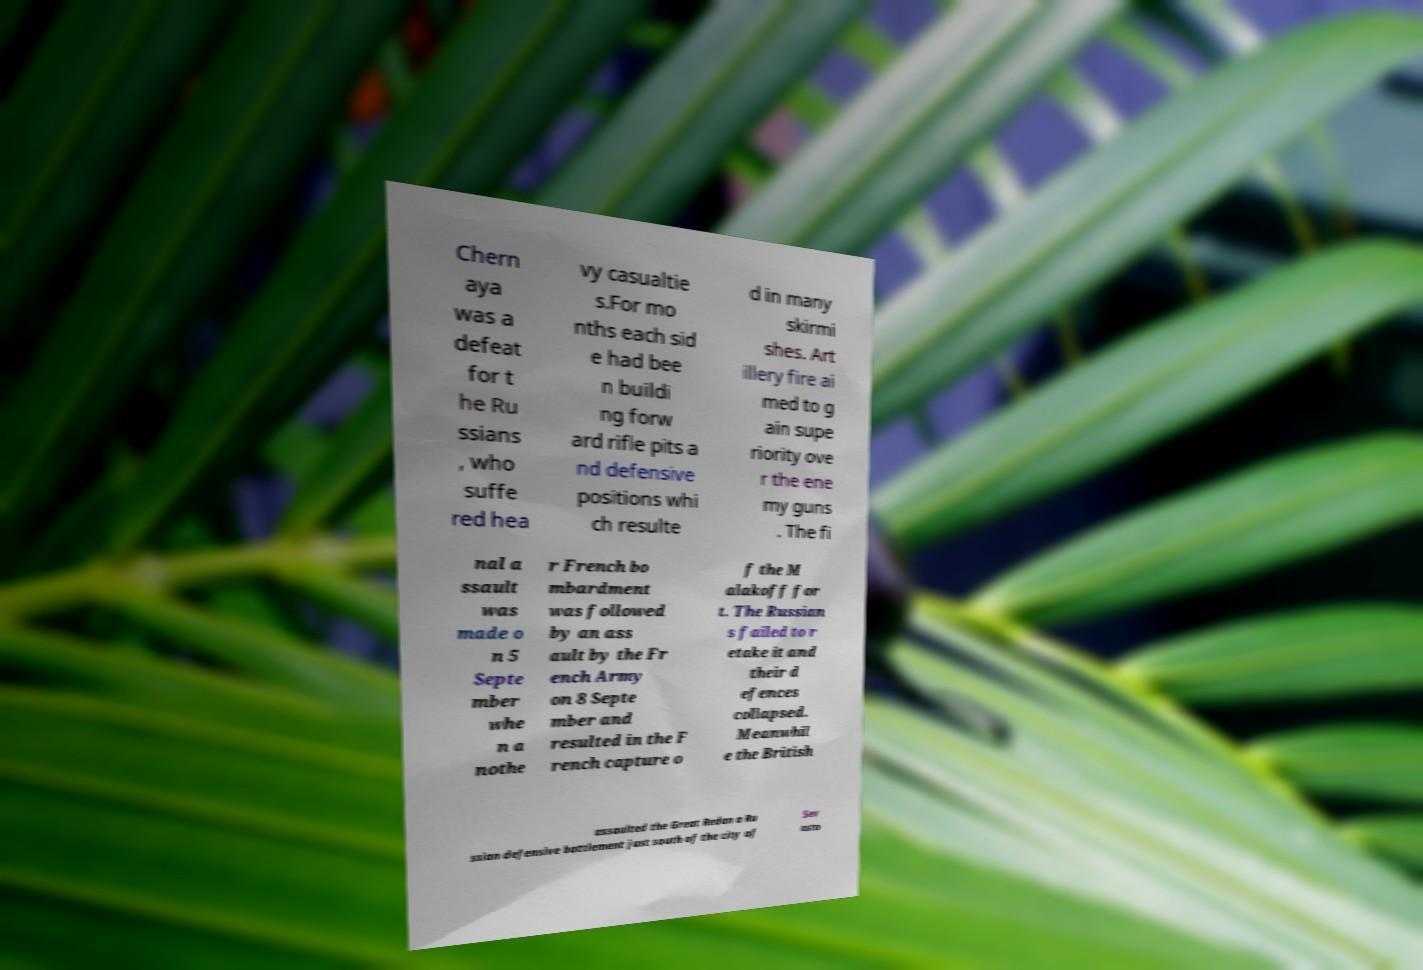There's text embedded in this image that I need extracted. Can you transcribe it verbatim? Chern aya was a defeat for t he Ru ssians , who suffe red hea vy casualtie s.For mo nths each sid e had bee n buildi ng forw ard rifle pits a nd defensive positions whi ch resulte d in many skirmi shes. Art illery fire ai med to g ain supe riority ove r the ene my guns . The fi nal a ssault was made o n 5 Septe mber whe n a nothe r French bo mbardment was followed by an ass ault by the Fr ench Army on 8 Septe mber and resulted in the F rench capture o f the M alakoff for t. The Russian s failed to r etake it and their d efences collapsed. Meanwhil e the British assaulted the Great Redan a Ru ssian defensive battlement just south of the city of Sev asto 